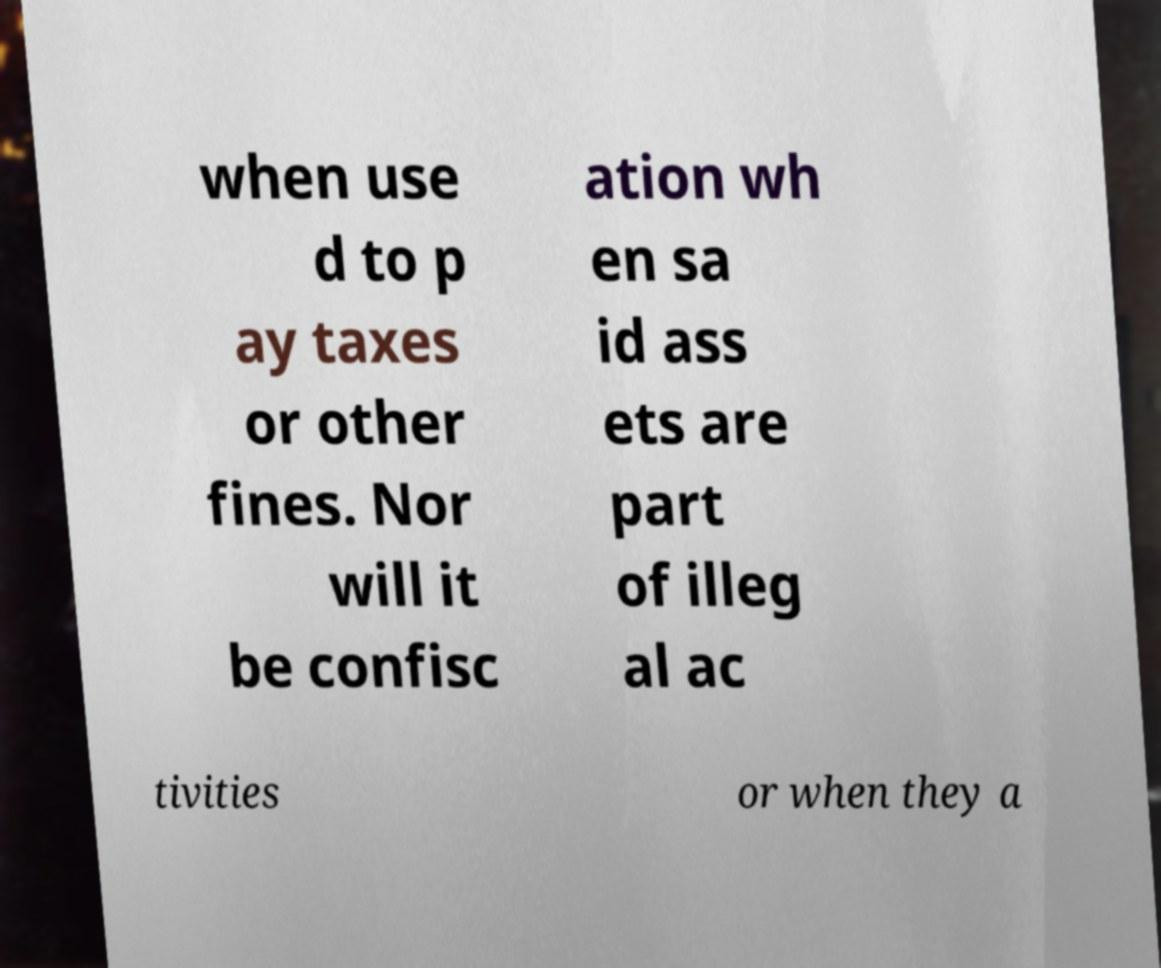Could you assist in decoding the text presented in this image and type it out clearly? when use d to p ay taxes or other fines. Nor will it be confisc ation wh en sa id ass ets are part of illeg al ac tivities or when they a 